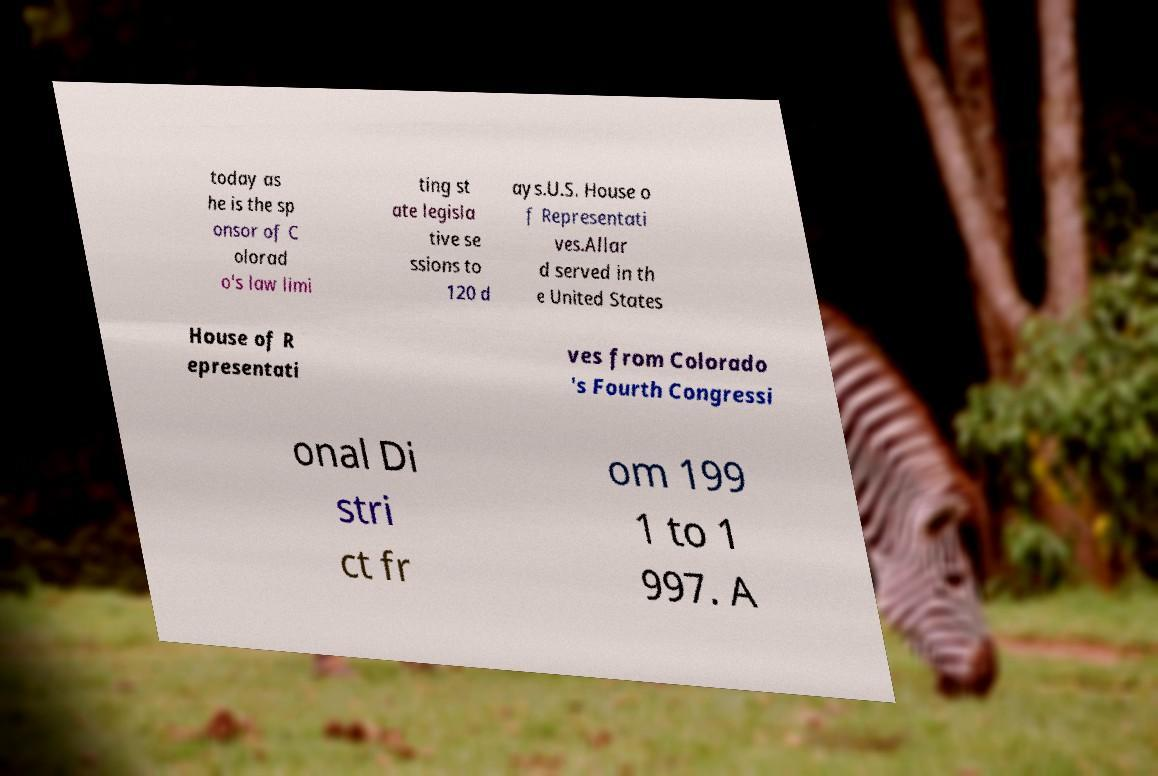Can you accurately transcribe the text from the provided image for me? today as he is the sp onsor of C olorad o's law limi ting st ate legisla tive se ssions to 120 d ays.U.S. House o f Representati ves.Allar d served in th e United States House of R epresentati ves from Colorado 's Fourth Congressi onal Di stri ct fr om 199 1 to 1 997. A 